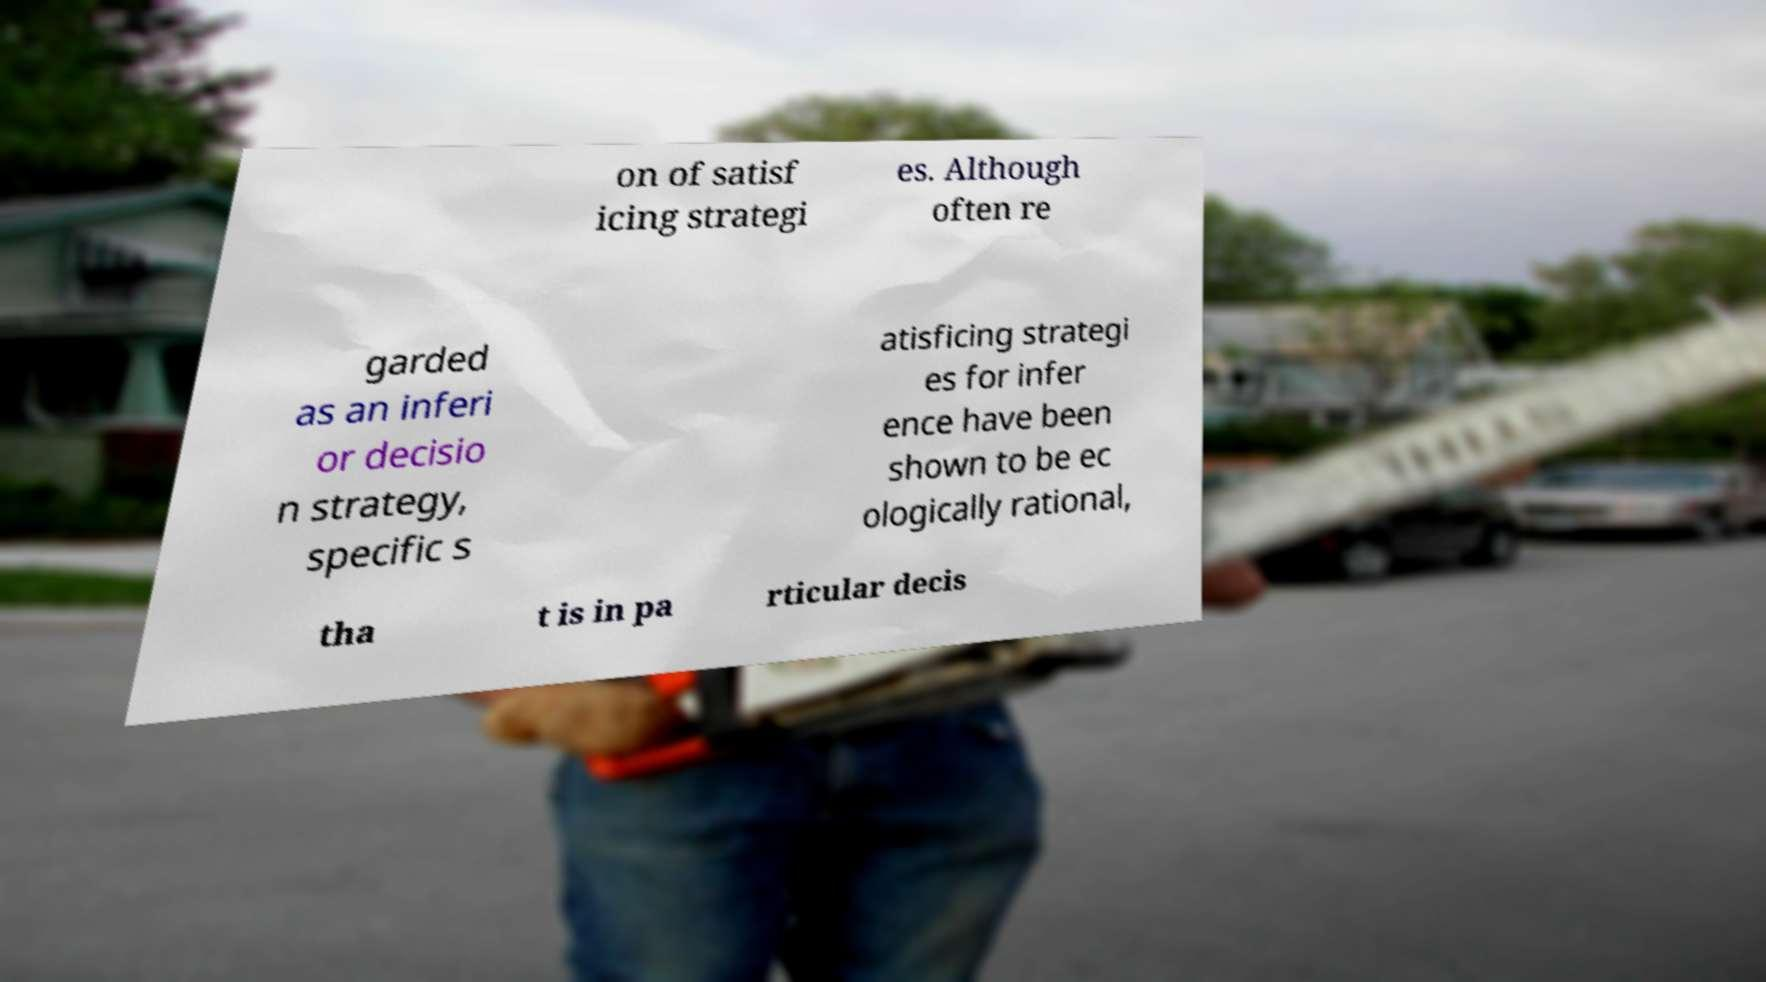Could you assist in decoding the text presented in this image and type it out clearly? on of satisf icing strategi es. Although often re garded as an inferi or decisio n strategy, specific s atisficing strategi es for infer ence have been shown to be ec ologically rational, tha t is in pa rticular decis 